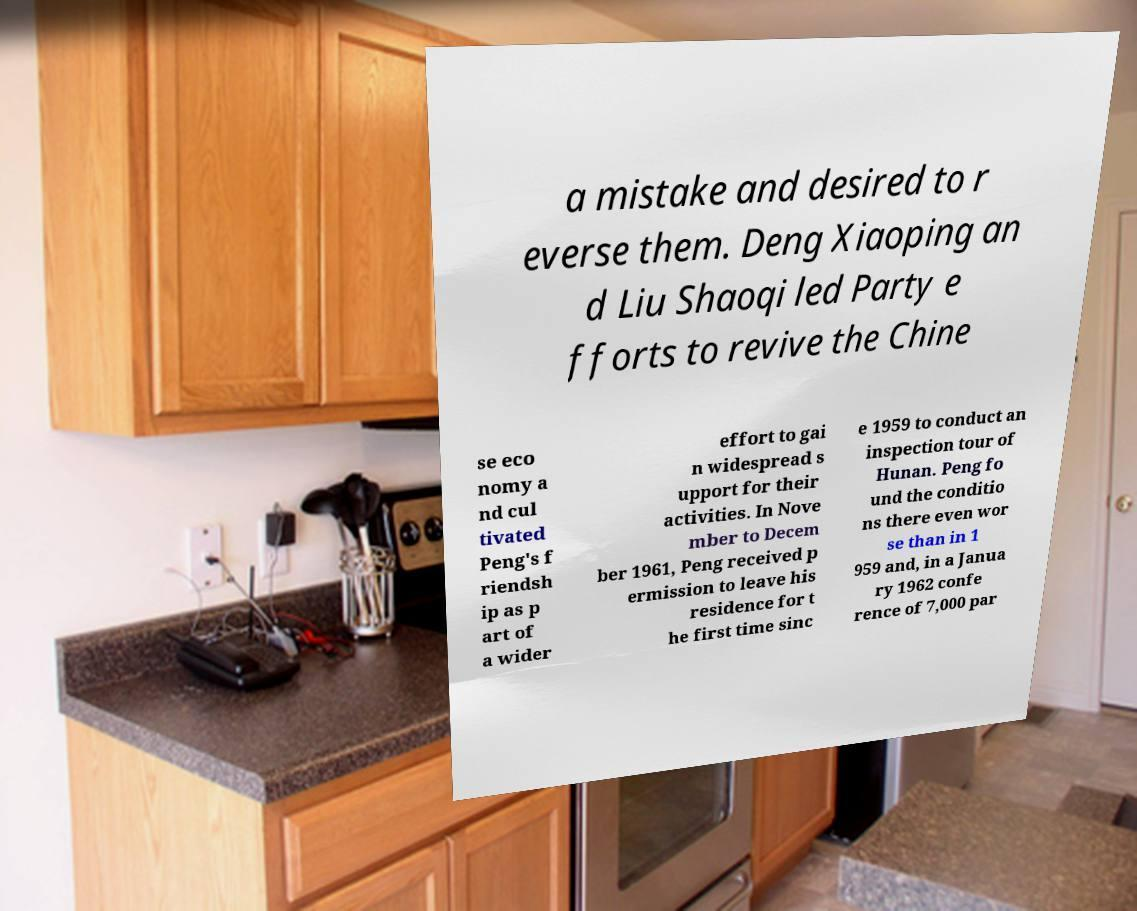There's text embedded in this image that I need extracted. Can you transcribe it verbatim? a mistake and desired to r everse them. Deng Xiaoping an d Liu Shaoqi led Party e fforts to revive the Chine se eco nomy a nd cul tivated Peng's f riendsh ip as p art of a wider effort to gai n widespread s upport for their activities. In Nove mber to Decem ber 1961, Peng received p ermission to leave his residence for t he first time sinc e 1959 to conduct an inspection tour of Hunan. Peng fo und the conditio ns there even wor se than in 1 959 and, in a Janua ry 1962 confe rence of 7,000 par 